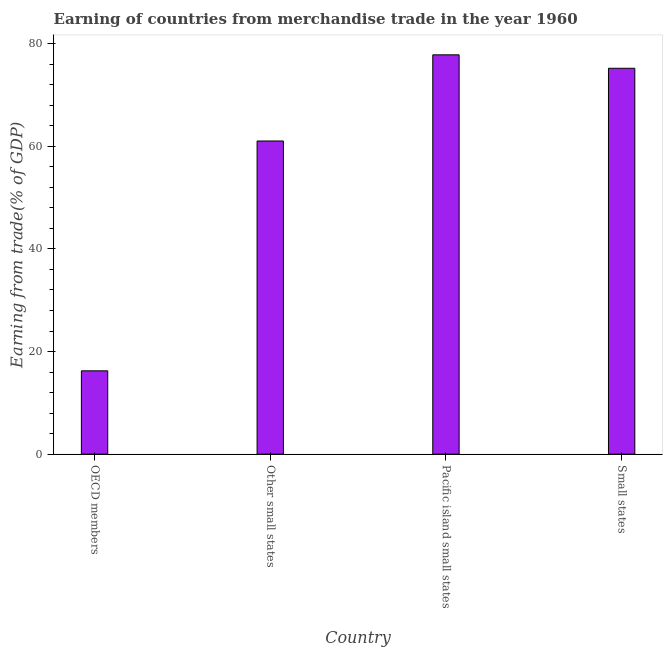What is the title of the graph?
Ensure brevity in your answer.  Earning of countries from merchandise trade in the year 1960. What is the label or title of the X-axis?
Offer a very short reply. Country. What is the label or title of the Y-axis?
Your answer should be compact. Earning from trade(% of GDP). What is the earning from merchandise trade in OECD members?
Offer a very short reply. 16.24. Across all countries, what is the maximum earning from merchandise trade?
Give a very brief answer. 77.82. Across all countries, what is the minimum earning from merchandise trade?
Your response must be concise. 16.24. In which country was the earning from merchandise trade maximum?
Ensure brevity in your answer.  Pacific island small states. What is the sum of the earning from merchandise trade?
Give a very brief answer. 230.29. What is the difference between the earning from merchandise trade in OECD members and Small states?
Make the answer very short. -58.96. What is the average earning from merchandise trade per country?
Provide a succinct answer. 57.57. What is the median earning from merchandise trade?
Your answer should be very brief. 68.12. What is the ratio of the earning from merchandise trade in Other small states to that in Pacific island small states?
Your response must be concise. 0.78. Is the earning from merchandise trade in Other small states less than that in Pacific island small states?
Give a very brief answer. Yes. Is the difference between the earning from merchandise trade in Pacific island small states and Small states greater than the difference between any two countries?
Give a very brief answer. No. What is the difference between the highest and the second highest earning from merchandise trade?
Give a very brief answer. 2.62. What is the difference between the highest and the lowest earning from merchandise trade?
Provide a succinct answer. 61.58. In how many countries, is the earning from merchandise trade greater than the average earning from merchandise trade taken over all countries?
Your answer should be compact. 3. How many bars are there?
Your response must be concise. 4. Are all the bars in the graph horizontal?
Give a very brief answer. No. How many countries are there in the graph?
Provide a succinct answer. 4. What is the Earning from trade(% of GDP) in OECD members?
Offer a terse response. 16.24. What is the Earning from trade(% of GDP) of Other small states?
Provide a short and direct response. 61.03. What is the Earning from trade(% of GDP) of Pacific island small states?
Offer a very short reply. 77.82. What is the Earning from trade(% of GDP) in Small states?
Ensure brevity in your answer.  75.2. What is the difference between the Earning from trade(% of GDP) in OECD members and Other small states?
Offer a very short reply. -44.79. What is the difference between the Earning from trade(% of GDP) in OECD members and Pacific island small states?
Keep it short and to the point. -61.58. What is the difference between the Earning from trade(% of GDP) in OECD members and Small states?
Give a very brief answer. -58.96. What is the difference between the Earning from trade(% of GDP) in Other small states and Pacific island small states?
Your answer should be compact. -16.79. What is the difference between the Earning from trade(% of GDP) in Other small states and Small states?
Keep it short and to the point. -14.17. What is the difference between the Earning from trade(% of GDP) in Pacific island small states and Small states?
Make the answer very short. 2.62. What is the ratio of the Earning from trade(% of GDP) in OECD members to that in Other small states?
Give a very brief answer. 0.27. What is the ratio of the Earning from trade(% of GDP) in OECD members to that in Pacific island small states?
Ensure brevity in your answer.  0.21. What is the ratio of the Earning from trade(% of GDP) in OECD members to that in Small states?
Offer a very short reply. 0.22. What is the ratio of the Earning from trade(% of GDP) in Other small states to that in Pacific island small states?
Make the answer very short. 0.78. What is the ratio of the Earning from trade(% of GDP) in Other small states to that in Small states?
Keep it short and to the point. 0.81. What is the ratio of the Earning from trade(% of GDP) in Pacific island small states to that in Small states?
Your answer should be very brief. 1.03. 